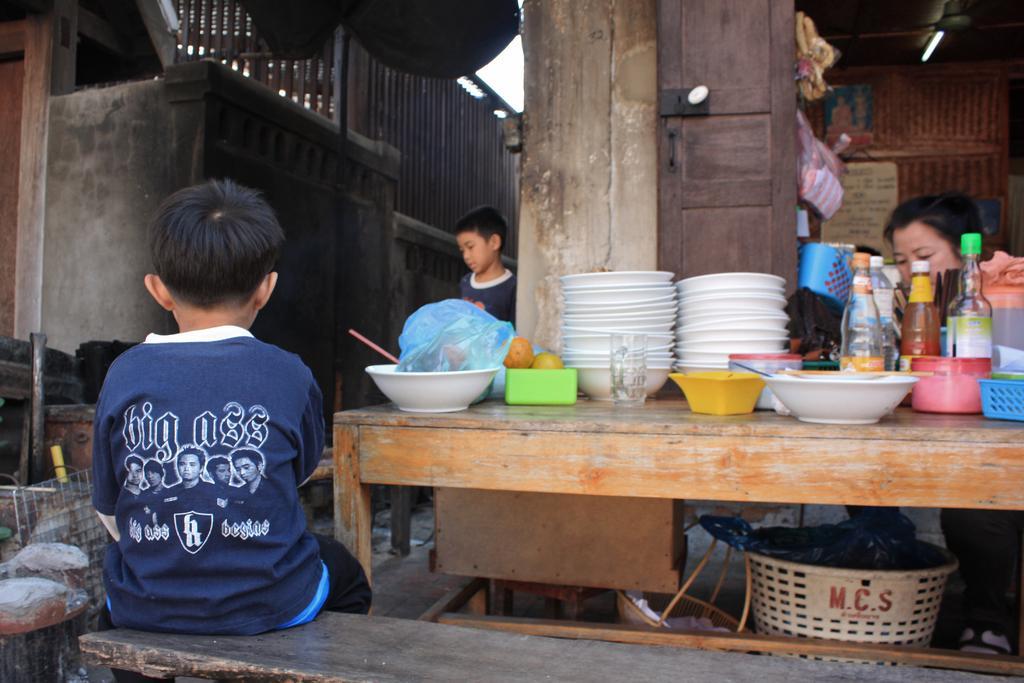Describe this image in one or two sentences. In this picture we can see two boys and one woman where here boy is sitting on bench and on table we can see bowls, bottles, plates, plastic cover, fruits and in background we can see wall, light. 